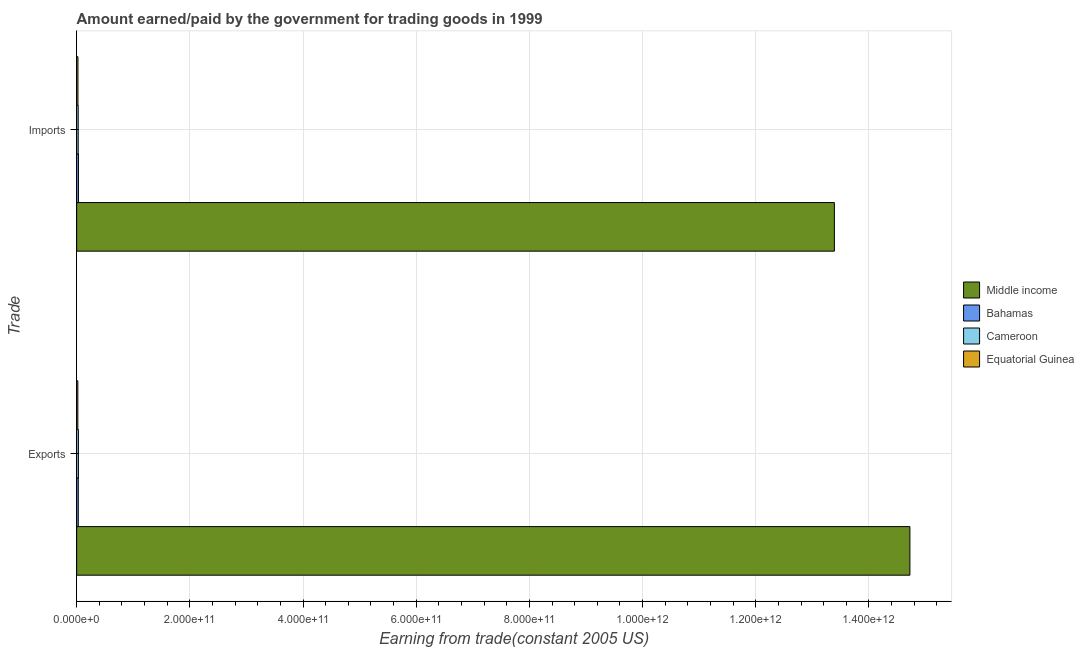How many different coloured bars are there?
Offer a terse response. 4. Are the number of bars per tick equal to the number of legend labels?
Keep it short and to the point. Yes. Are the number of bars on each tick of the Y-axis equal?
Offer a very short reply. Yes. How many bars are there on the 1st tick from the top?
Offer a terse response. 4. What is the label of the 2nd group of bars from the top?
Offer a very short reply. Exports. What is the amount earned from exports in Middle income?
Make the answer very short. 1.47e+12. Across all countries, what is the maximum amount paid for imports?
Your answer should be compact. 1.34e+12. Across all countries, what is the minimum amount paid for imports?
Give a very brief answer. 2.26e+09. In which country was the amount earned from exports maximum?
Ensure brevity in your answer.  Middle income. In which country was the amount paid for imports minimum?
Your answer should be very brief. Equatorial Guinea. What is the total amount earned from exports in the graph?
Make the answer very short. 1.48e+12. What is the difference between the amount earned from exports in Cameroon and that in Bahamas?
Provide a succinct answer. 2.45e+08. What is the difference between the amount paid for imports in Middle income and the amount earned from exports in Equatorial Guinea?
Offer a terse response. 1.34e+12. What is the average amount earned from exports per country?
Ensure brevity in your answer.  3.70e+11. What is the difference between the amount earned from exports and amount paid for imports in Middle income?
Your answer should be compact. 1.33e+11. In how many countries, is the amount earned from exports greater than 440000000000 US$?
Provide a short and direct response. 1. What is the ratio of the amount paid for imports in Middle income to that in Equatorial Guinea?
Your response must be concise. 592.94. In how many countries, is the amount earned from exports greater than the average amount earned from exports taken over all countries?
Provide a short and direct response. 1. What does the 2nd bar from the top in Exports represents?
Ensure brevity in your answer.  Cameroon. What does the 2nd bar from the bottom in Exports represents?
Ensure brevity in your answer.  Bahamas. Are all the bars in the graph horizontal?
Ensure brevity in your answer.  Yes. How many countries are there in the graph?
Give a very brief answer. 4. What is the difference between two consecutive major ticks on the X-axis?
Provide a succinct answer. 2.00e+11. Does the graph contain any zero values?
Make the answer very short. No. How many legend labels are there?
Ensure brevity in your answer.  4. How are the legend labels stacked?
Your response must be concise. Vertical. What is the title of the graph?
Your answer should be compact. Amount earned/paid by the government for trading goods in 1999. What is the label or title of the X-axis?
Your response must be concise. Earning from trade(constant 2005 US). What is the label or title of the Y-axis?
Your answer should be very brief. Trade. What is the Earning from trade(constant 2005 US) of Middle income in Exports?
Your answer should be compact. 1.47e+12. What is the Earning from trade(constant 2005 US) of Bahamas in Exports?
Offer a very short reply. 2.85e+09. What is the Earning from trade(constant 2005 US) of Cameroon in Exports?
Make the answer very short. 3.10e+09. What is the Earning from trade(constant 2005 US) of Equatorial Guinea in Exports?
Your answer should be compact. 2.06e+09. What is the Earning from trade(constant 2005 US) in Middle income in Imports?
Keep it short and to the point. 1.34e+12. What is the Earning from trade(constant 2005 US) of Bahamas in Imports?
Ensure brevity in your answer.  3.16e+09. What is the Earning from trade(constant 2005 US) in Cameroon in Imports?
Your answer should be compact. 2.73e+09. What is the Earning from trade(constant 2005 US) of Equatorial Guinea in Imports?
Offer a very short reply. 2.26e+09. Across all Trade, what is the maximum Earning from trade(constant 2005 US) of Middle income?
Your answer should be very brief. 1.47e+12. Across all Trade, what is the maximum Earning from trade(constant 2005 US) of Bahamas?
Ensure brevity in your answer.  3.16e+09. Across all Trade, what is the maximum Earning from trade(constant 2005 US) in Cameroon?
Keep it short and to the point. 3.10e+09. Across all Trade, what is the maximum Earning from trade(constant 2005 US) in Equatorial Guinea?
Make the answer very short. 2.26e+09. Across all Trade, what is the minimum Earning from trade(constant 2005 US) in Middle income?
Provide a succinct answer. 1.34e+12. Across all Trade, what is the minimum Earning from trade(constant 2005 US) of Bahamas?
Make the answer very short. 2.85e+09. Across all Trade, what is the minimum Earning from trade(constant 2005 US) of Cameroon?
Keep it short and to the point. 2.73e+09. Across all Trade, what is the minimum Earning from trade(constant 2005 US) of Equatorial Guinea?
Your answer should be very brief. 2.06e+09. What is the total Earning from trade(constant 2005 US) in Middle income in the graph?
Keep it short and to the point. 2.81e+12. What is the total Earning from trade(constant 2005 US) in Bahamas in the graph?
Keep it short and to the point. 6.01e+09. What is the total Earning from trade(constant 2005 US) of Cameroon in the graph?
Make the answer very short. 5.83e+09. What is the total Earning from trade(constant 2005 US) of Equatorial Guinea in the graph?
Provide a short and direct response. 4.31e+09. What is the difference between the Earning from trade(constant 2005 US) of Middle income in Exports and that in Imports?
Provide a short and direct response. 1.33e+11. What is the difference between the Earning from trade(constant 2005 US) of Bahamas in Exports and that in Imports?
Your answer should be very brief. -3.03e+08. What is the difference between the Earning from trade(constant 2005 US) of Cameroon in Exports and that in Imports?
Provide a short and direct response. 3.73e+08. What is the difference between the Earning from trade(constant 2005 US) of Equatorial Guinea in Exports and that in Imports?
Keep it short and to the point. -2.03e+08. What is the difference between the Earning from trade(constant 2005 US) in Middle income in Exports and the Earning from trade(constant 2005 US) in Bahamas in Imports?
Provide a short and direct response. 1.47e+12. What is the difference between the Earning from trade(constant 2005 US) of Middle income in Exports and the Earning from trade(constant 2005 US) of Cameroon in Imports?
Your answer should be compact. 1.47e+12. What is the difference between the Earning from trade(constant 2005 US) of Middle income in Exports and the Earning from trade(constant 2005 US) of Equatorial Guinea in Imports?
Your response must be concise. 1.47e+12. What is the difference between the Earning from trade(constant 2005 US) in Bahamas in Exports and the Earning from trade(constant 2005 US) in Cameroon in Imports?
Make the answer very short. 1.28e+08. What is the difference between the Earning from trade(constant 2005 US) of Bahamas in Exports and the Earning from trade(constant 2005 US) of Equatorial Guinea in Imports?
Offer a terse response. 5.96e+08. What is the difference between the Earning from trade(constant 2005 US) in Cameroon in Exports and the Earning from trade(constant 2005 US) in Equatorial Guinea in Imports?
Give a very brief answer. 8.41e+08. What is the average Earning from trade(constant 2005 US) of Middle income per Trade?
Keep it short and to the point. 1.41e+12. What is the average Earning from trade(constant 2005 US) in Bahamas per Trade?
Offer a very short reply. 3.01e+09. What is the average Earning from trade(constant 2005 US) in Cameroon per Trade?
Offer a very short reply. 2.91e+09. What is the average Earning from trade(constant 2005 US) in Equatorial Guinea per Trade?
Give a very brief answer. 2.16e+09. What is the difference between the Earning from trade(constant 2005 US) in Middle income and Earning from trade(constant 2005 US) in Bahamas in Exports?
Provide a short and direct response. 1.47e+12. What is the difference between the Earning from trade(constant 2005 US) of Middle income and Earning from trade(constant 2005 US) of Cameroon in Exports?
Keep it short and to the point. 1.47e+12. What is the difference between the Earning from trade(constant 2005 US) of Middle income and Earning from trade(constant 2005 US) of Equatorial Guinea in Exports?
Your answer should be compact. 1.47e+12. What is the difference between the Earning from trade(constant 2005 US) in Bahamas and Earning from trade(constant 2005 US) in Cameroon in Exports?
Provide a short and direct response. -2.45e+08. What is the difference between the Earning from trade(constant 2005 US) of Bahamas and Earning from trade(constant 2005 US) of Equatorial Guinea in Exports?
Ensure brevity in your answer.  7.99e+08. What is the difference between the Earning from trade(constant 2005 US) in Cameroon and Earning from trade(constant 2005 US) in Equatorial Guinea in Exports?
Your answer should be compact. 1.04e+09. What is the difference between the Earning from trade(constant 2005 US) of Middle income and Earning from trade(constant 2005 US) of Bahamas in Imports?
Keep it short and to the point. 1.34e+12. What is the difference between the Earning from trade(constant 2005 US) of Middle income and Earning from trade(constant 2005 US) of Cameroon in Imports?
Make the answer very short. 1.34e+12. What is the difference between the Earning from trade(constant 2005 US) of Middle income and Earning from trade(constant 2005 US) of Equatorial Guinea in Imports?
Provide a succinct answer. 1.34e+12. What is the difference between the Earning from trade(constant 2005 US) in Bahamas and Earning from trade(constant 2005 US) in Cameroon in Imports?
Your answer should be compact. 4.32e+08. What is the difference between the Earning from trade(constant 2005 US) in Bahamas and Earning from trade(constant 2005 US) in Equatorial Guinea in Imports?
Keep it short and to the point. 9.00e+08. What is the difference between the Earning from trade(constant 2005 US) of Cameroon and Earning from trade(constant 2005 US) of Equatorial Guinea in Imports?
Your answer should be very brief. 4.68e+08. What is the ratio of the Earning from trade(constant 2005 US) in Middle income in Exports to that in Imports?
Ensure brevity in your answer.  1.1. What is the ratio of the Earning from trade(constant 2005 US) in Bahamas in Exports to that in Imports?
Give a very brief answer. 0.9. What is the ratio of the Earning from trade(constant 2005 US) of Cameroon in Exports to that in Imports?
Give a very brief answer. 1.14. What is the ratio of the Earning from trade(constant 2005 US) in Equatorial Guinea in Exports to that in Imports?
Give a very brief answer. 0.91. What is the difference between the highest and the second highest Earning from trade(constant 2005 US) of Middle income?
Provide a short and direct response. 1.33e+11. What is the difference between the highest and the second highest Earning from trade(constant 2005 US) in Bahamas?
Give a very brief answer. 3.03e+08. What is the difference between the highest and the second highest Earning from trade(constant 2005 US) in Cameroon?
Your answer should be compact. 3.73e+08. What is the difference between the highest and the second highest Earning from trade(constant 2005 US) in Equatorial Guinea?
Keep it short and to the point. 2.03e+08. What is the difference between the highest and the lowest Earning from trade(constant 2005 US) in Middle income?
Make the answer very short. 1.33e+11. What is the difference between the highest and the lowest Earning from trade(constant 2005 US) of Bahamas?
Offer a terse response. 3.03e+08. What is the difference between the highest and the lowest Earning from trade(constant 2005 US) of Cameroon?
Your answer should be compact. 3.73e+08. What is the difference between the highest and the lowest Earning from trade(constant 2005 US) of Equatorial Guinea?
Ensure brevity in your answer.  2.03e+08. 